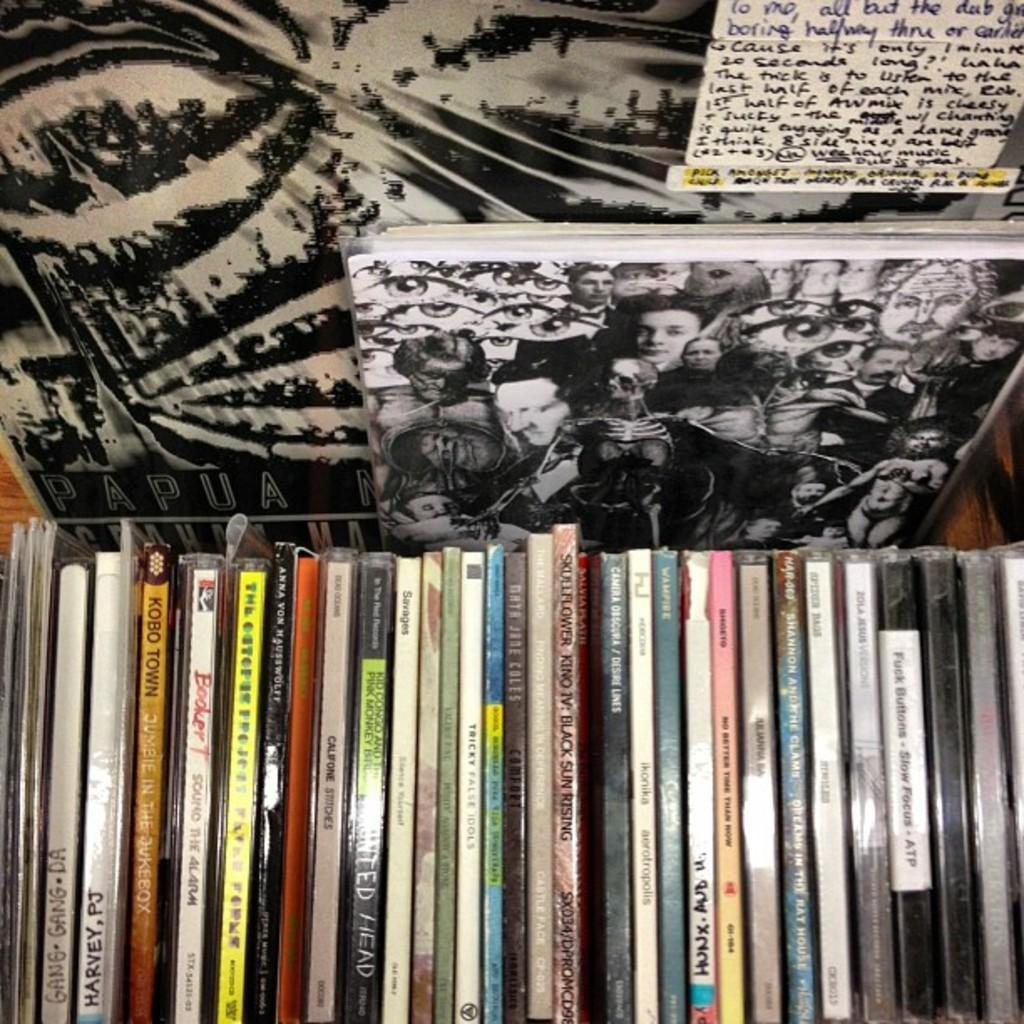What is the name of the first now handwritten cd from the left?
Give a very brief answer. Gang gang da. 